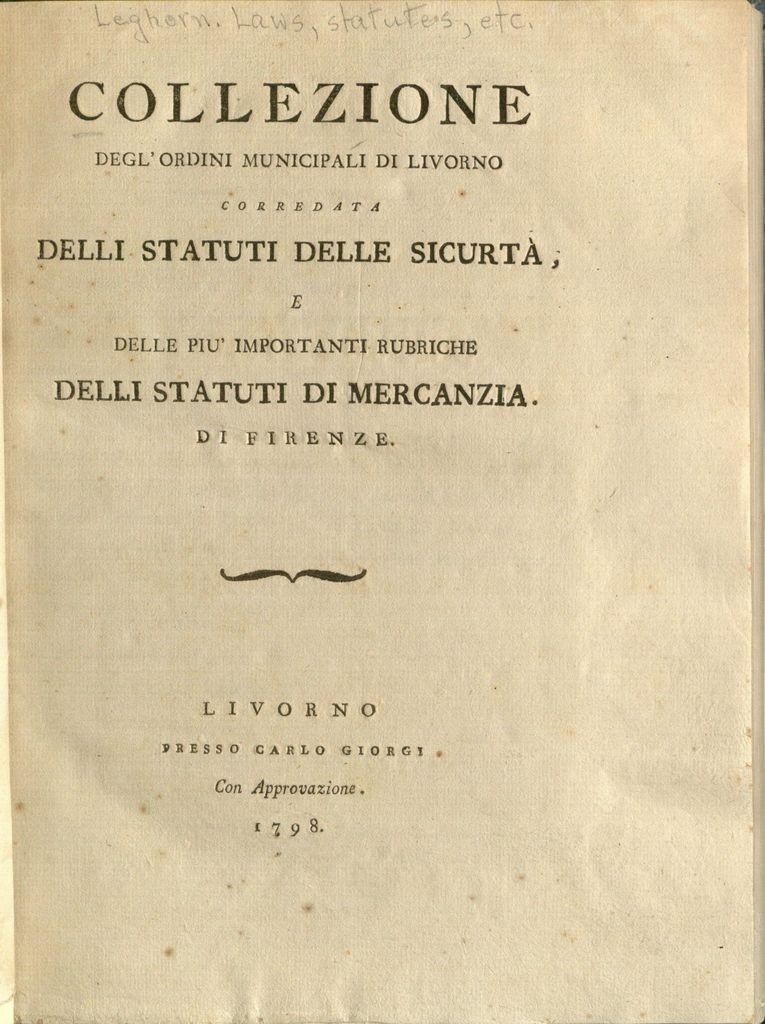<image>
Relay a brief, clear account of the picture shown. A page from a book that was written in 1798. 